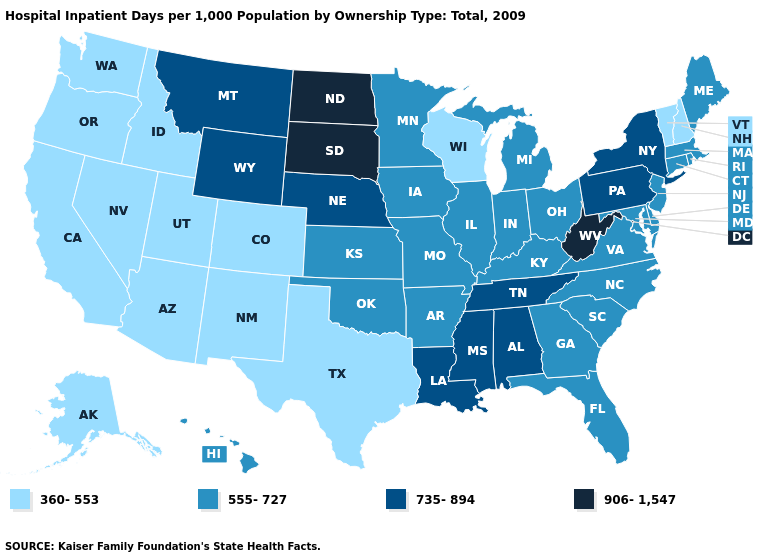Is the legend a continuous bar?
Give a very brief answer. No. How many symbols are there in the legend?
Short answer required. 4. How many symbols are there in the legend?
Concise answer only. 4. Does Missouri have the highest value in the MidWest?
Short answer required. No. How many symbols are there in the legend?
Write a very short answer. 4. Among the states that border Pennsylvania , which have the lowest value?
Be succinct. Delaware, Maryland, New Jersey, Ohio. Does Pennsylvania have the highest value in the Northeast?
Give a very brief answer. Yes. Name the states that have a value in the range 360-553?
Write a very short answer. Alaska, Arizona, California, Colorado, Idaho, Nevada, New Hampshire, New Mexico, Oregon, Texas, Utah, Vermont, Washington, Wisconsin. Does Montana have the lowest value in the West?
Be succinct. No. What is the highest value in the USA?
Keep it brief. 906-1,547. Does the map have missing data?
Give a very brief answer. No. Which states have the highest value in the USA?
Be succinct. North Dakota, South Dakota, West Virginia. What is the value of Alabama?
Short answer required. 735-894. What is the highest value in states that border New Hampshire?
Concise answer only. 555-727. Among the states that border Maine , which have the highest value?
Quick response, please. New Hampshire. 